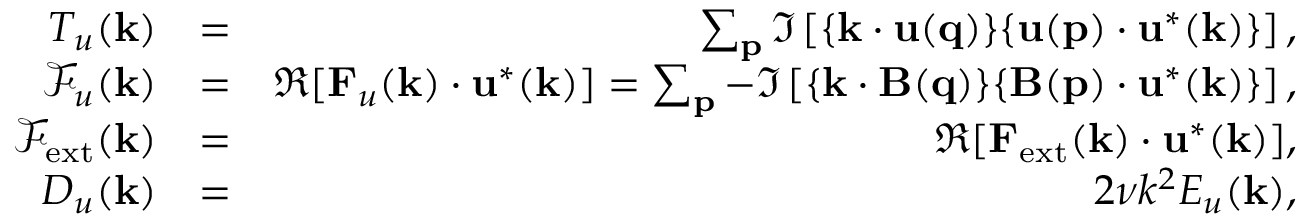Convert formula to latex. <formula><loc_0><loc_0><loc_500><loc_500>\begin{array} { r l r } { T _ { u } ( { k } ) } & { = } & { \sum _ { p } \Im \left [ { \{ k \cdot u ( q ) \} \{ u ( p ) \cdot u ^ { * } ( k ) \} } \right ] , } \\ { \mathcal { F } _ { u } ( { k } ) } & { = } & { \Re [ { F } _ { u } ( { k } ) \cdot { u } ^ { * } ( { k } ) ] = \sum _ { p } - \Im \left [ { \{ k \cdot B ( q ) \} \{ B ( p ) \cdot u ^ { * } ( k ) \} } \right ] , } \\ { \mathcal { F } _ { e x t } ( { k } ) } & { = } & { \Re [ { F } _ { e x t } ( { k } ) \cdot { u } ^ { * } ( { k } ) ] , } \\ { D _ { u } ( k ) } & { = } & { 2 \nu k ^ { 2 } E _ { u } ( { k } ) , } \end{array}</formula> 